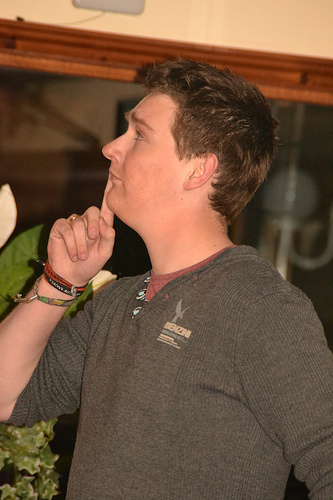<image>
Is the finger in the head? No. The finger is not contained within the head. These objects have a different spatial relationship. 